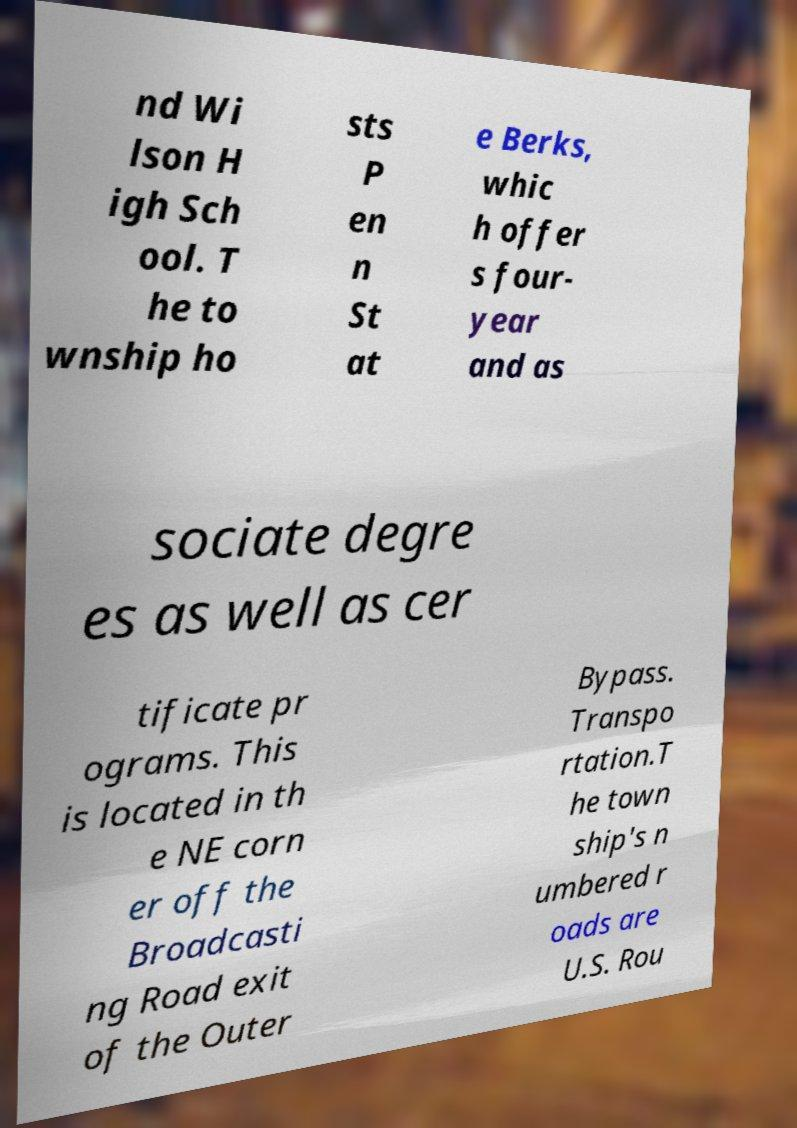Can you read and provide the text displayed in the image?This photo seems to have some interesting text. Can you extract and type it out for me? nd Wi lson H igh Sch ool. T he to wnship ho sts P en n St at e Berks, whic h offer s four- year and as sociate degre es as well as cer tificate pr ograms. This is located in th e NE corn er off the Broadcasti ng Road exit of the Outer Bypass. Transpo rtation.T he town ship's n umbered r oads are U.S. Rou 